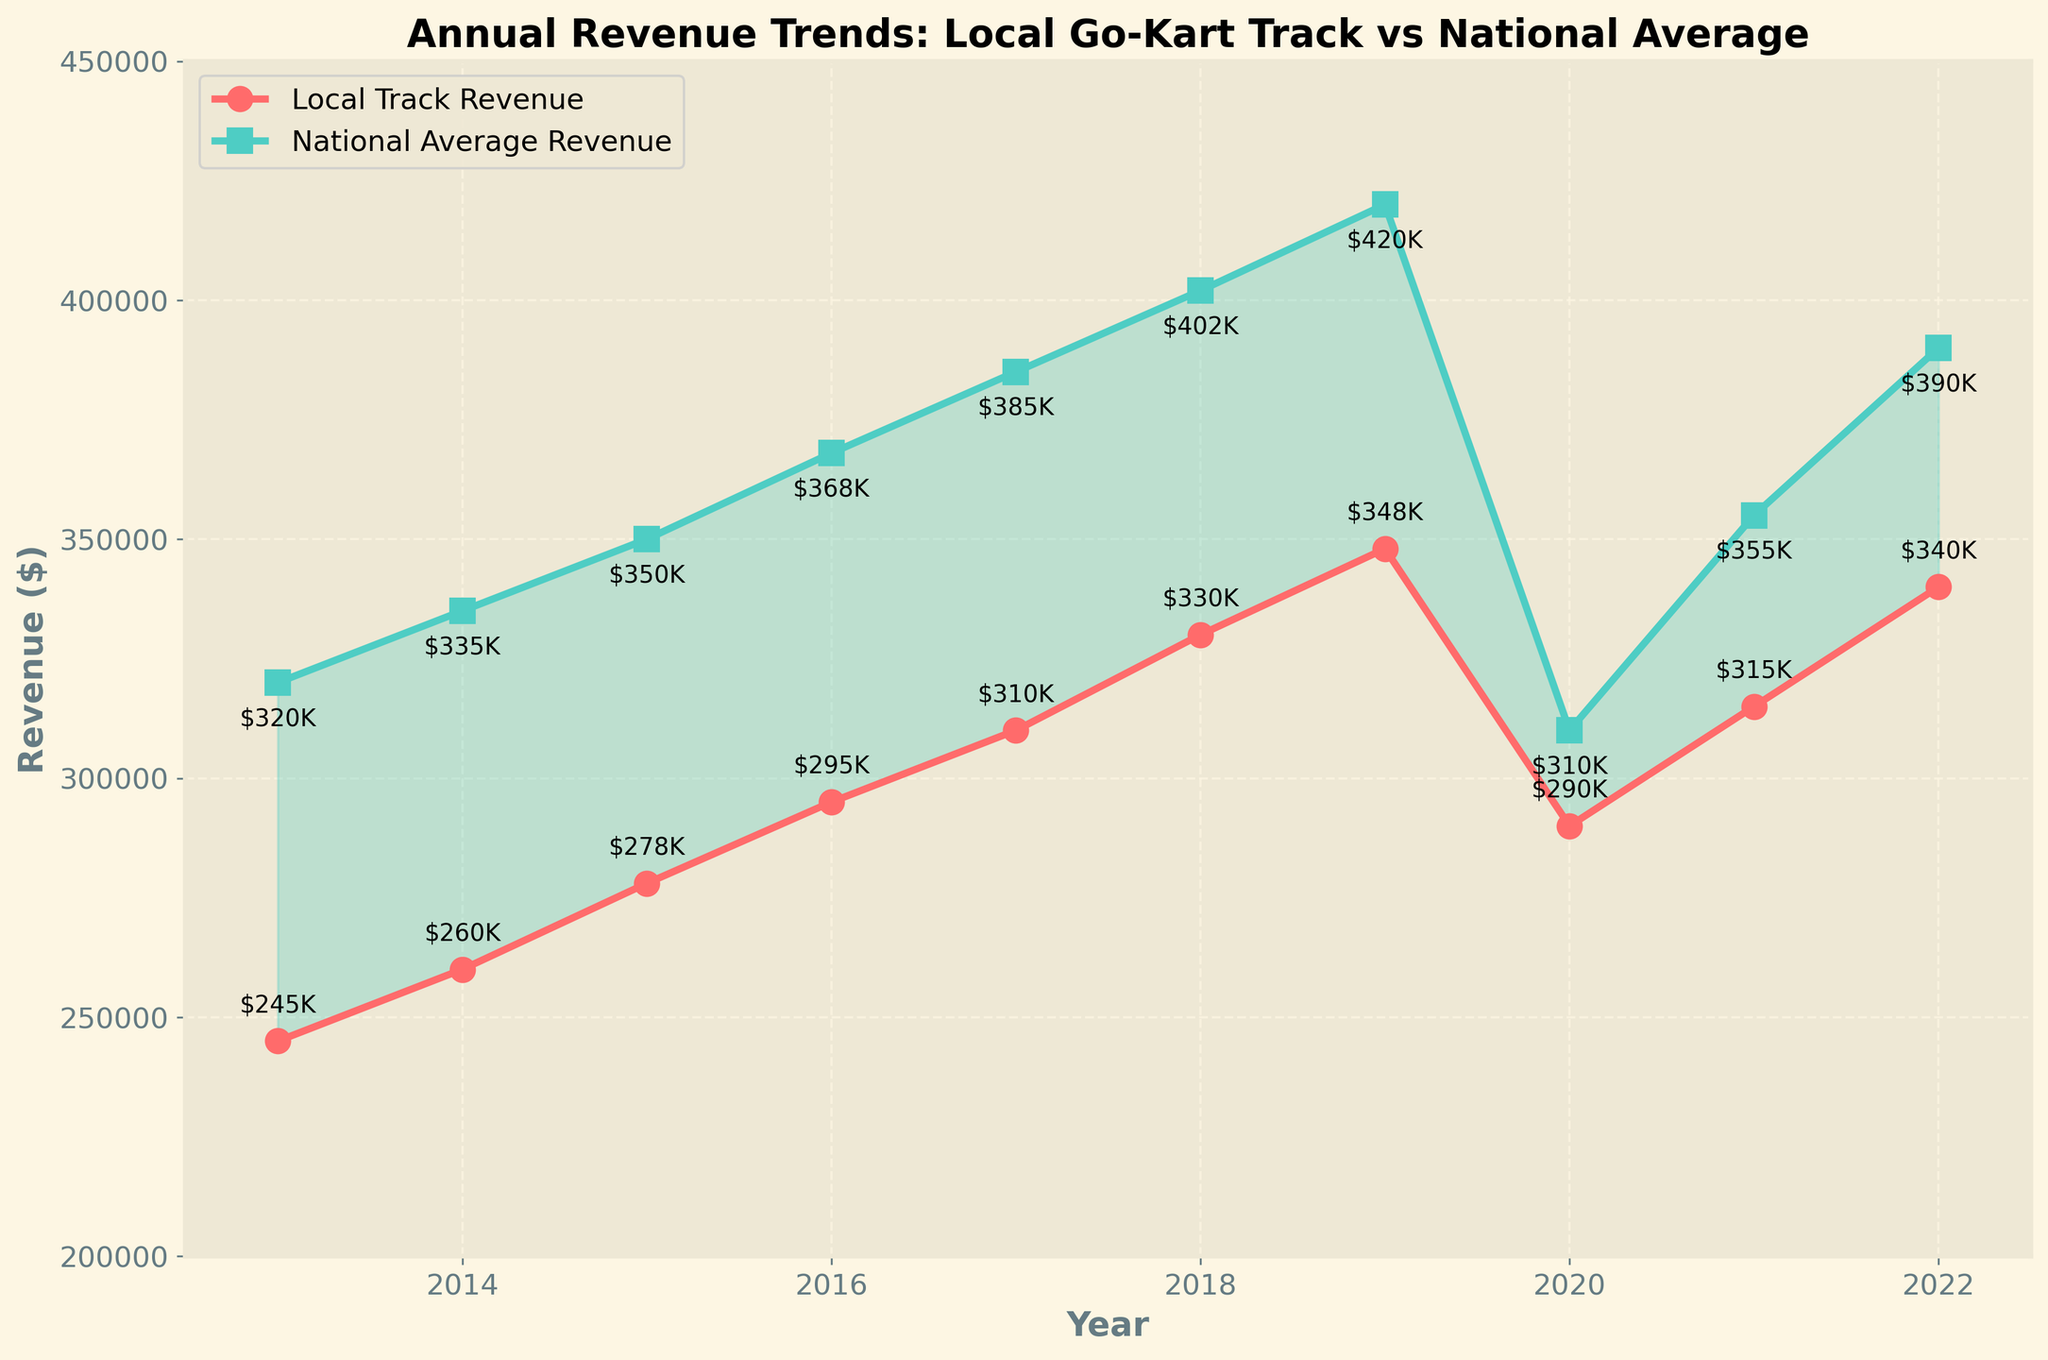Which year had the highest revenue for the local go-kart track? The highest local revenue occurred at the peak value shown on the plot. This is visually identified as the year 2019, where the marker reaches its highest point before declining.
Answer: 2019 What is the revenue gap between the national average and the local go-kart track in 2016? Identify the national average revenue (368,000) and the local track revenue (295,000) for the year 2016, then calculate the difference: 368,000 - 295,000.
Answer: 73,000 In which year did the local go-kart track's revenue drop sharply, and how does this year compare to the national average revenue for the same year? The local track's revenue dropped noticeably in 2020, declining to 290,000. In the same year, the national average revenue also dropped to 310,000, marking a general downturn.
Answer: 2020; lower than national average What is the average revenue for the local track over the first five years (2013-2017)? Sum the local track revenues from 2013 to 2017: 245,000 + 260,000 + 278,000 + 295,000 + 310,000 = 1,388,000. Divide by 5 to get the average.
Answer: 277,600 In which year did the national average revenue exceed the local track revenue by the largest margin? The largest revenue gap is visualized where the shaded area between the two lines is widest. This can be identified as occurring in 2019, where there is a significant difference between 420,000 (national) and 348,000 (local).
Answer: 2019 How much did the local track’s revenue increase from 2014 to 2015? Local revenue in 2014 was 260,000, and in 2015 it was 278,000. Thus, the increase is 278,000 - 260,000.
Answer: 18,000 Compare the trends of local revenue and national average revenue before and after 2020. What main differences can you observe? Before 2020, both trends are generally increasing with some fluctuations. After 2020, while national revenue resumes significant growth, peaking at 390,000 in 2022, the local revenue grows more steadily but not as sharply, peaking at 340,000 in 2022.
Answer: National revenue grows faster after 2020 How many years did the local track's revenue grow continuously without a decline? From the graph, the local track's revenue grew each year from 2013 to 2019 without a dip. This is a continuous upward trend visible every year up to 2019.
Answer: 6 years In which year was the local track’s revenue closest to the national average, and what was the gap? The gap was smallest in 2020, where the local revenue (290,000) was closest to the national average (310,000). The gap is calculated as 310,000 - 290,000.
Answer: 2020; 20,000 